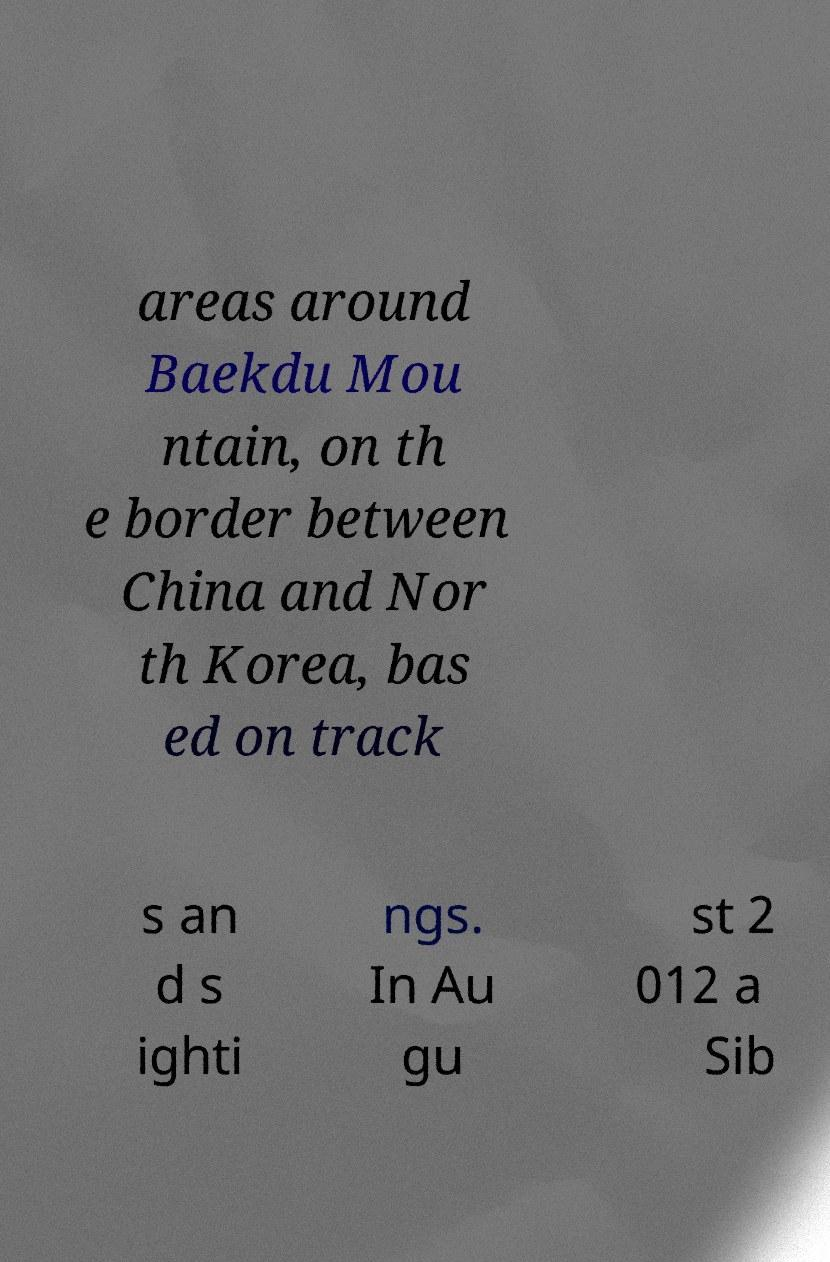Could you assist in decoding the text presented in this image and type it out clearly? areas around Baekdu Mou ntain, on th e border between China and Nor th Korea, bas ed on track s an d s ighti ngs. In Au gu st 2 012 a Sib 